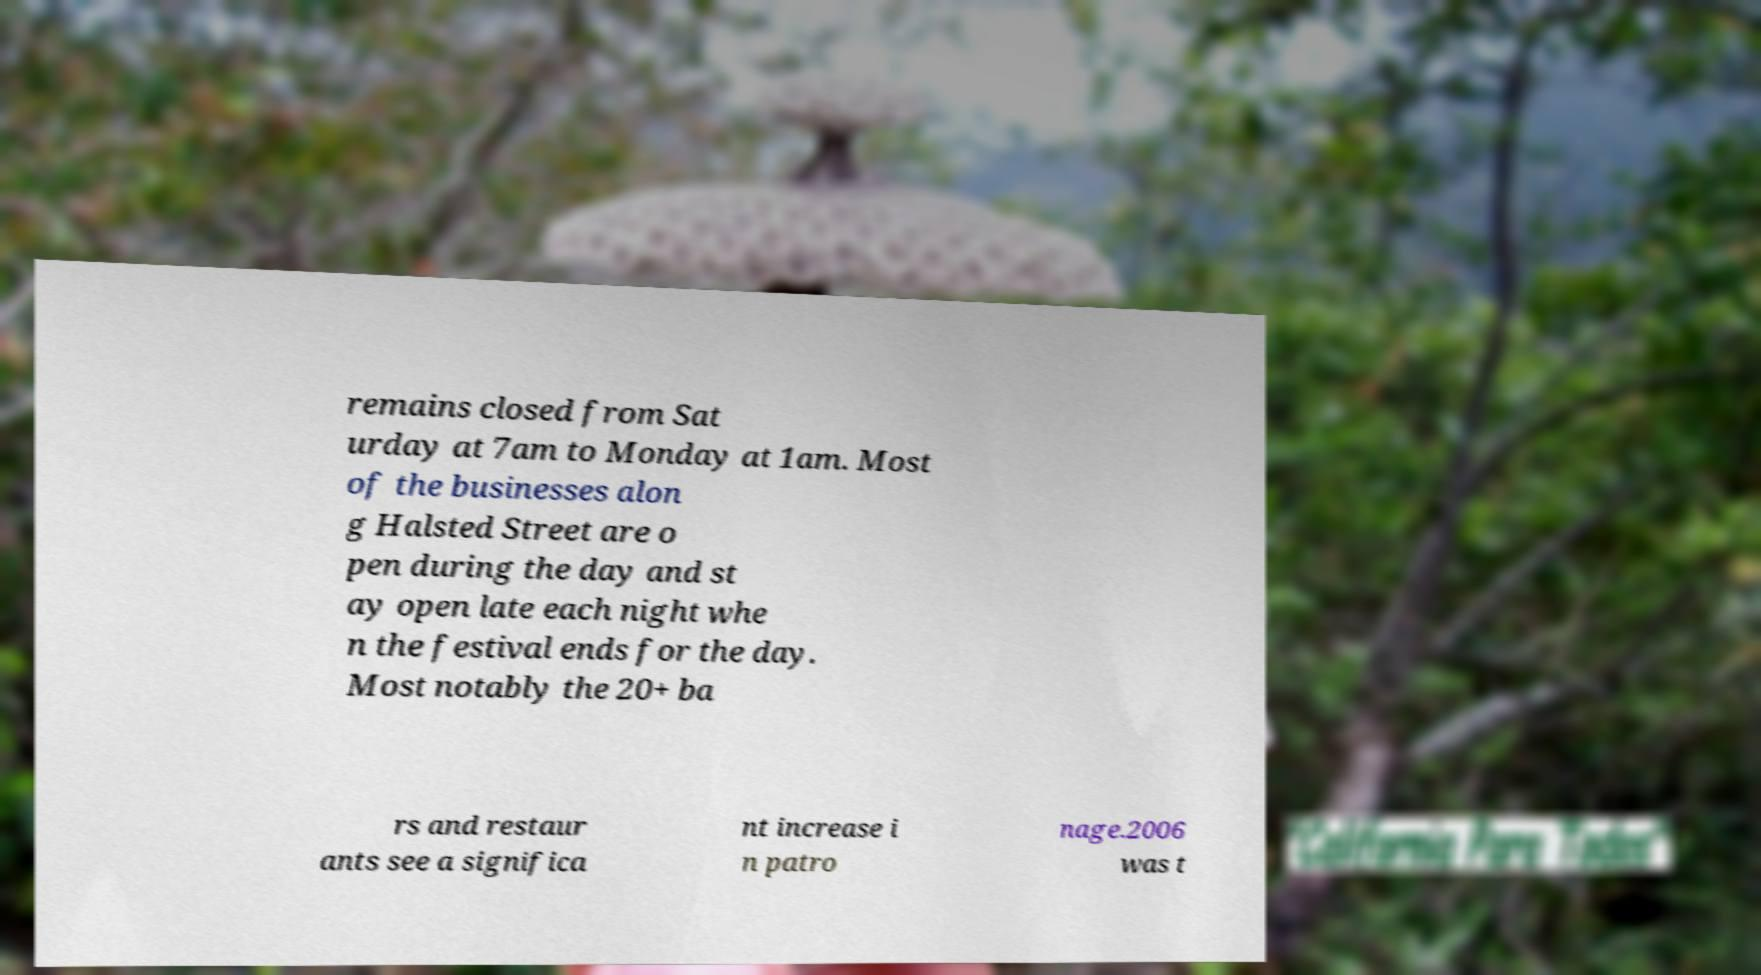Can you read and provide the text displayed in the image?This photo seems to have some interesting text. Can you extract and type it out for me? remains closed from Sat urday at 7am to Monday at 1am. Most of the businesses alon g Halsted Street are o pen during the day and st ay open late each night whe n the festival ends for the day. Most notably the 20+ ba rs and restaur ants see a significa nt increase i n patro nage.2006 was t 